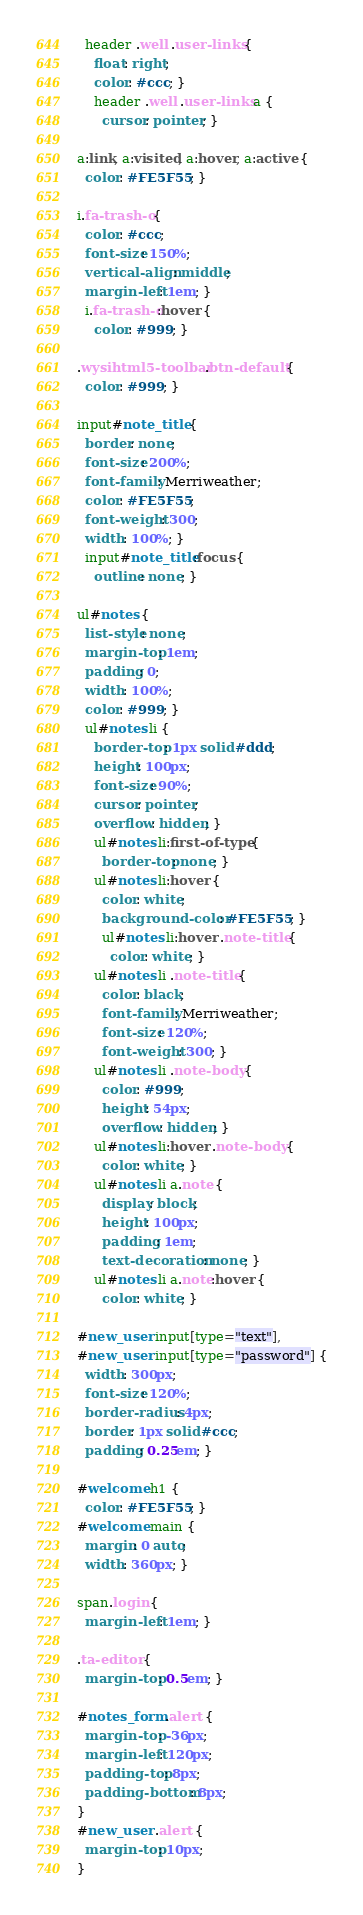<code> <loc_0><loc_0><loc_500><loc_500><_CSS_>  header .well .user-links {
    float: right;
    color: #ccc; }
    header .well .user-links a {
      cursor: pointer; }

a:link, a:visited, a:hover, a:active {
  color: #FE5F55; }

i.fa-trash-o {
  color: #ccc;
  font-size: 150%;
  vertical-align: middle;
  margin-left: 1em; }
  i.fa-trash-o:hover {
    color: #999; }

.wysihtml5-toolbar .btn-default {
  color: #999; }

input#note_title {
  border: none;
  font-size: 200%;
  font-family: Merriweather;
  color: #FE5F55;
  font-weight: 300;
  width: 100%; }
  input#note_title:focus {
    outline: none; }

ul#notes {
  list-style: none;
  margin-top: 1em;
  padding: 0;
  width: 100%;
  color: #999; }
  ul#notes li {
    border-top: 1px solid #ddd;
    height: 100px;
    font-size: 90%;
    cursor: pointer;
    overflow: hidden; }
    ul#notes li:first-of-type {
      border-top: none; }
    ul#notes li:hover {
      color: white;
      background-color: #FE5F55; }
      ul#notes li:hover .note-title {
        color: white; }
    ul#notes li .note-title {
      color: black;
      font-family: Merriweather;
      font-size: 120%;
      font-weight: 300; }
    ul#notes li .note-body {
      color: #999;
      height: 54px;
      overflow: hidden; }
    ul#notes li:hover .note-body {
      color: white; }
    ul#notes li a.note {
      display: block;
      height: 100px;
      padding: 1em;
      text-decoration: none; }
    ul#notes li a.note:hover {
      color: white; }

#new_user input[type="text"],
#new_user input[type="password"] {
  width: 300px;
  font-size: 120%;
  border-radius: 4px;
  border: 1px solid #ccc;
  padding: 0.25em; }

#welcome h1 {
  color: #FE5F55; }
#welcome main {
  margin: 0 auto;
  width: 360px; }

span.login {
  margin-left: 1em; }

.ta-editor {
  margin-top: 0.5em; }

#notes_form .alert {
  margin-top: -36px;
  margin-left: 120px;
  padding-top: 8px;
  padding-bottom: 8px;
}
#new_user .alert {
  margin-top: 10px;
}
</code> 